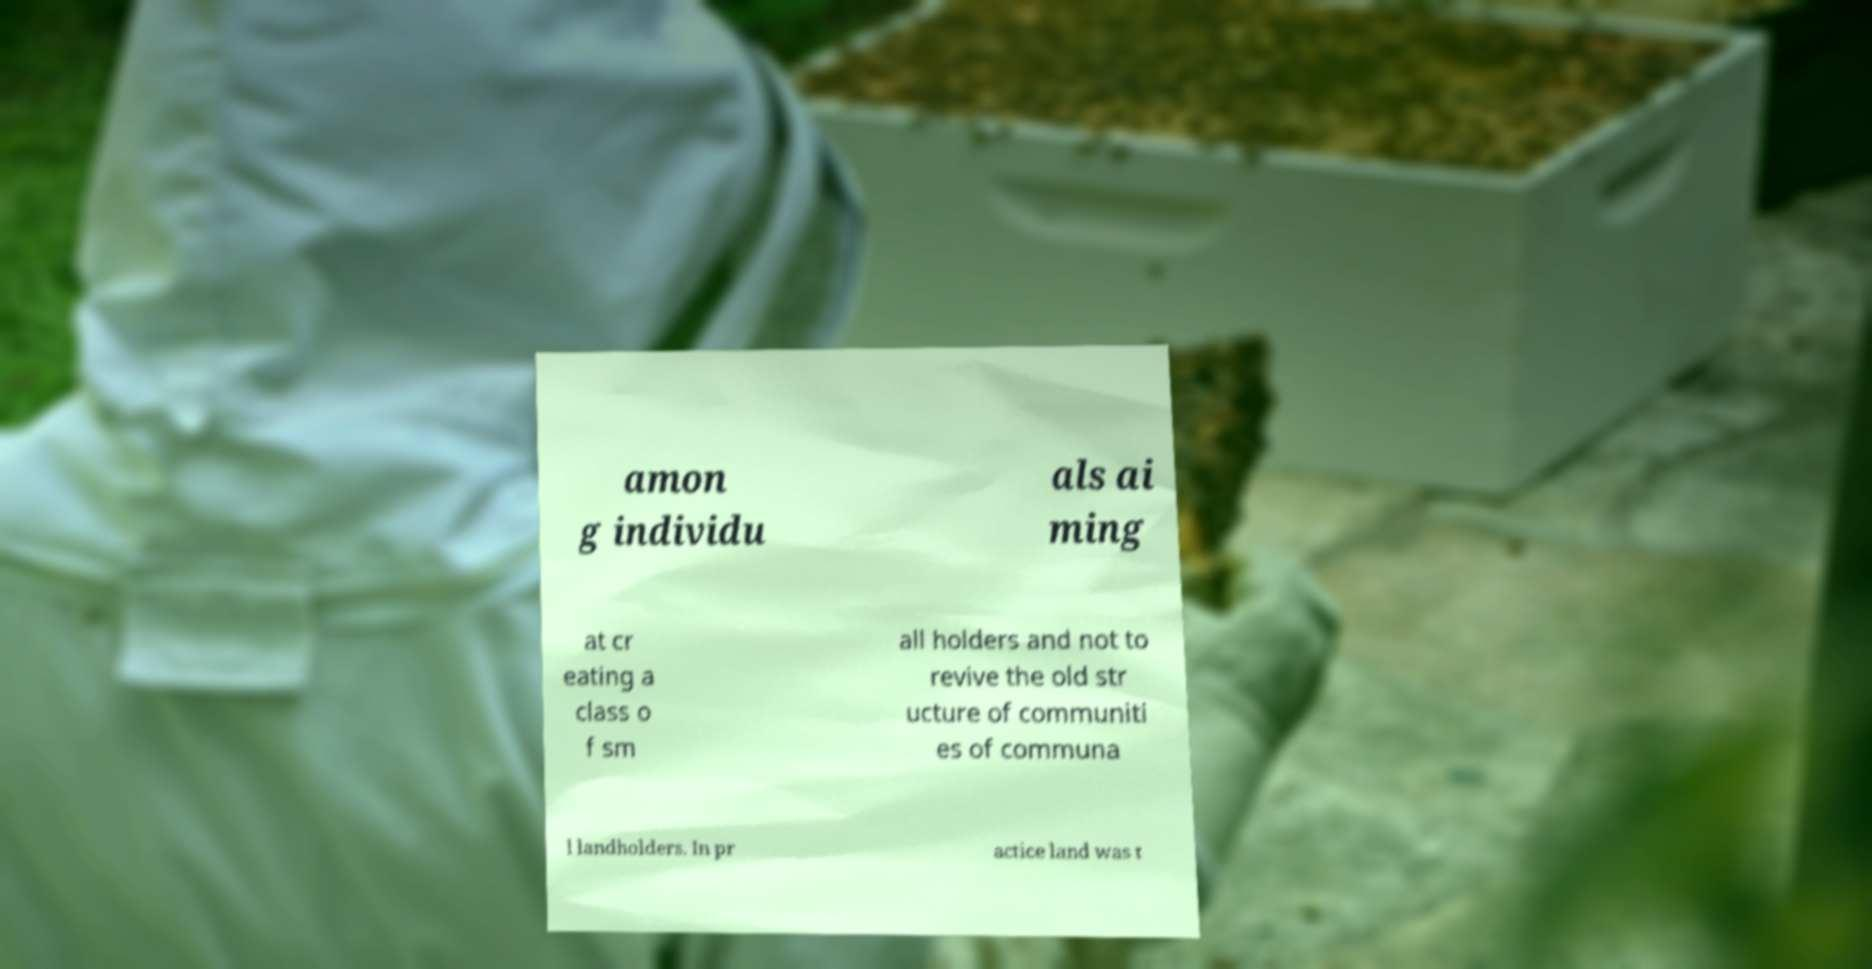For documentation purposes, I need the text within this image transcribed. Could you provide that? amon g individu als ai ming at cr eating a class o f sm all holders and not to revive the old str ucture of communiti es of communa l landholders. In pr actice land was t 